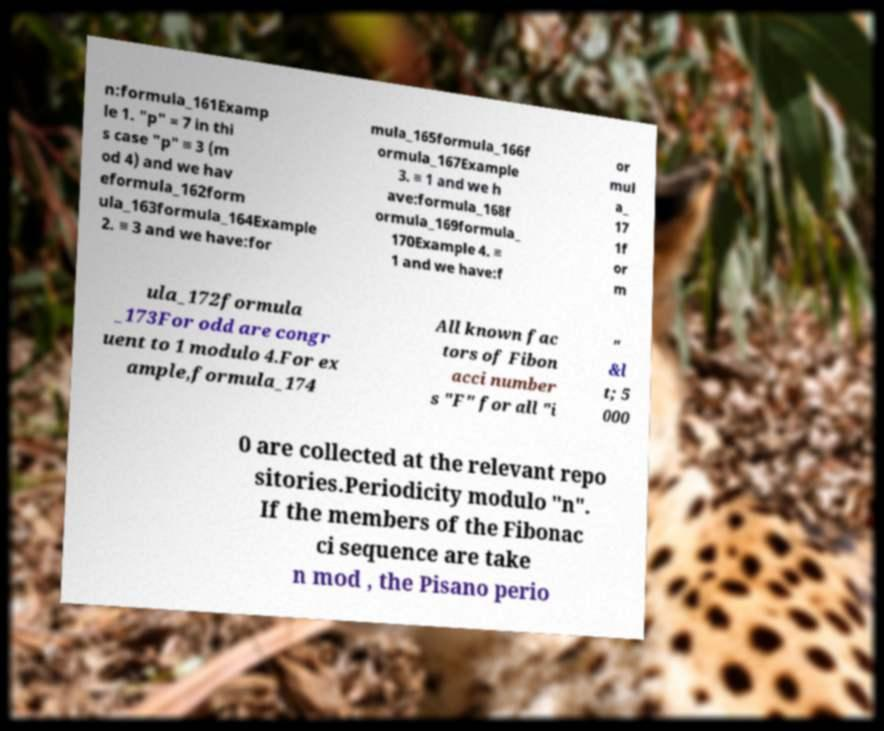For documentation purposes, I need the text within this image transcribed. Could you provide that? n:formula_161Examp le 1. "p" = 7 in thi s case "p" ≡ 3 (m od 4) and we hav eformula_162form ula_163formula_164Example 2. ≡ 3 and we have:for mula_165formula_166f ormula_167Example 3. ≡ 1 and we h ave:formula_168f ormula_169formula_ 170Example 4. ≡ 1 and we have:f or mul a_ 17 1f or m ula_172formula _173For odd are congr uent to 1 modulo 4.For ex ample,formula_174 All known fac tors of Fibon acci number s "F" for all "i " &l t; 5 000 0 are collected at the relevant repo sitories.Periodicity modulo "n". If the members of the Fibonac ci sequence are take n mod , the Pisano perio 